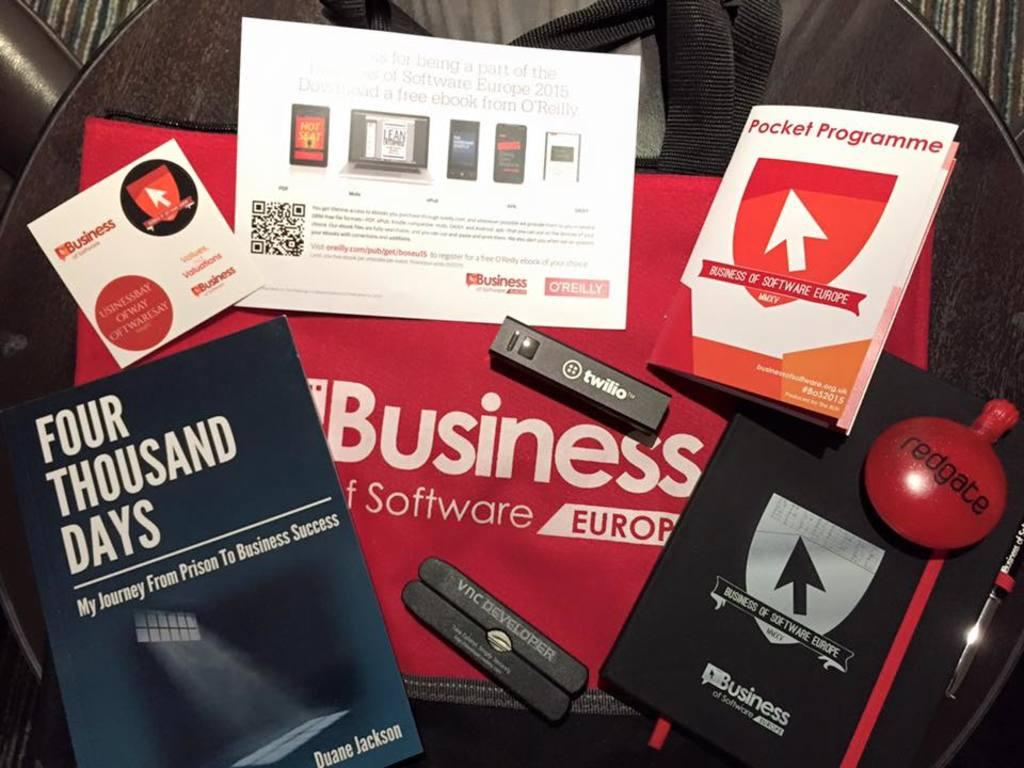<image>
Provide a brief description of the given image. A bunch of books, one of which is called Four Thousand Days. 